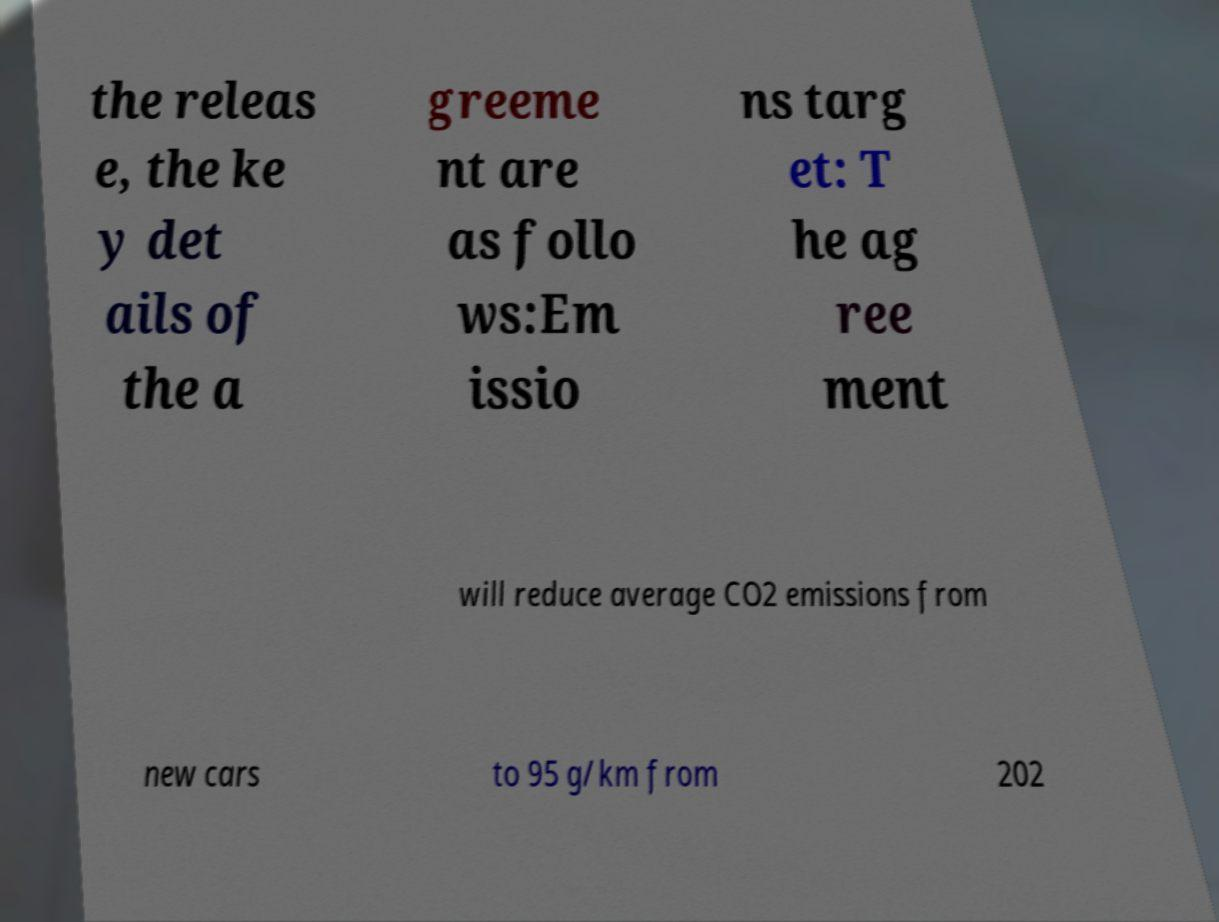Could you assist in decoding the text presented in this image and type it out clearly? the releas e, the ke y det ails of the a greeme nt are as follo ws:Em issio ns targ et: T he ag ree ment will reduce average CO2 emissions from new cars to 95 g/km from 202 